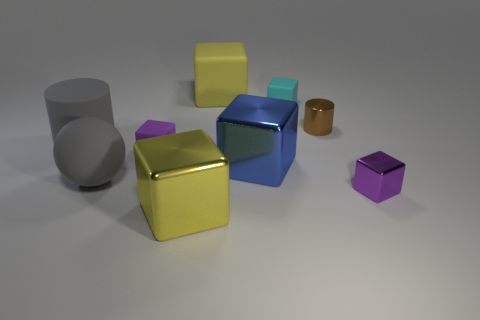There is a blue object that is the same shape as the purple metal thing; what is its size?
Give a very brief answer. Large. Is the number of large metal cubes that are on the right side of the cyan matte block less than the number of cyan rubber objects?
Provide a short and direct response. Yes. Is the color of the large shiny thing behind the tiny purple metal object the same as the small metal cylinder?
Keep it short and to the point. No. What number of matte objects are big blue blocks or big cylinders?
Your response must be concise. 1. What color is the big block that is the same material as the cyan thing?
Give a very brief answer. Yellow. What number of balls are big yellow rubber things or big shiny things?
Keep it short and to the point. 0. How many things are large blue shiny cubes or large cubes that are on the right side of the large yellow shiny object?
Your response must be concise. 2. Is there a big blue cylinder?
Offer a terse response. No. How many rubber cylinders have the same color as the matte sphere?
Keep it short and to the point. 1. What is the material of the large cylinder that is the same color as the rubber sphere?
Provide a short and direct response. Rubber. 